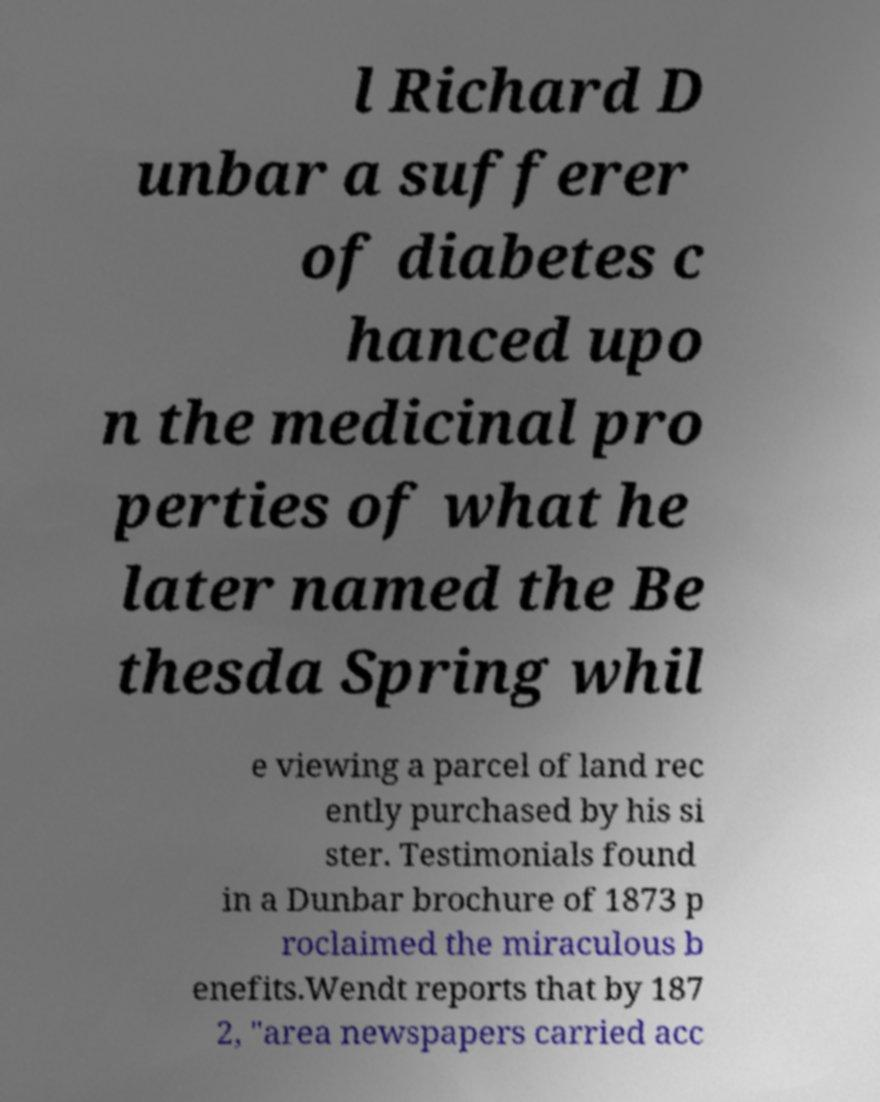For documentation purposes, I need the text within this image transcribed. Could you provide that? l Richard D unbar a sufferer of diabetes c hanced upo n the medicinal pro perties of what he later named the Be thesda Spring whil e viewing a parcel of land rec ently purchased by his si ster. Testimonials found in a Dunbar brochure of 1873 p roclaimed the miraculous b enefits.Wendt reports that by 187 2, "area newspapers carried acc 